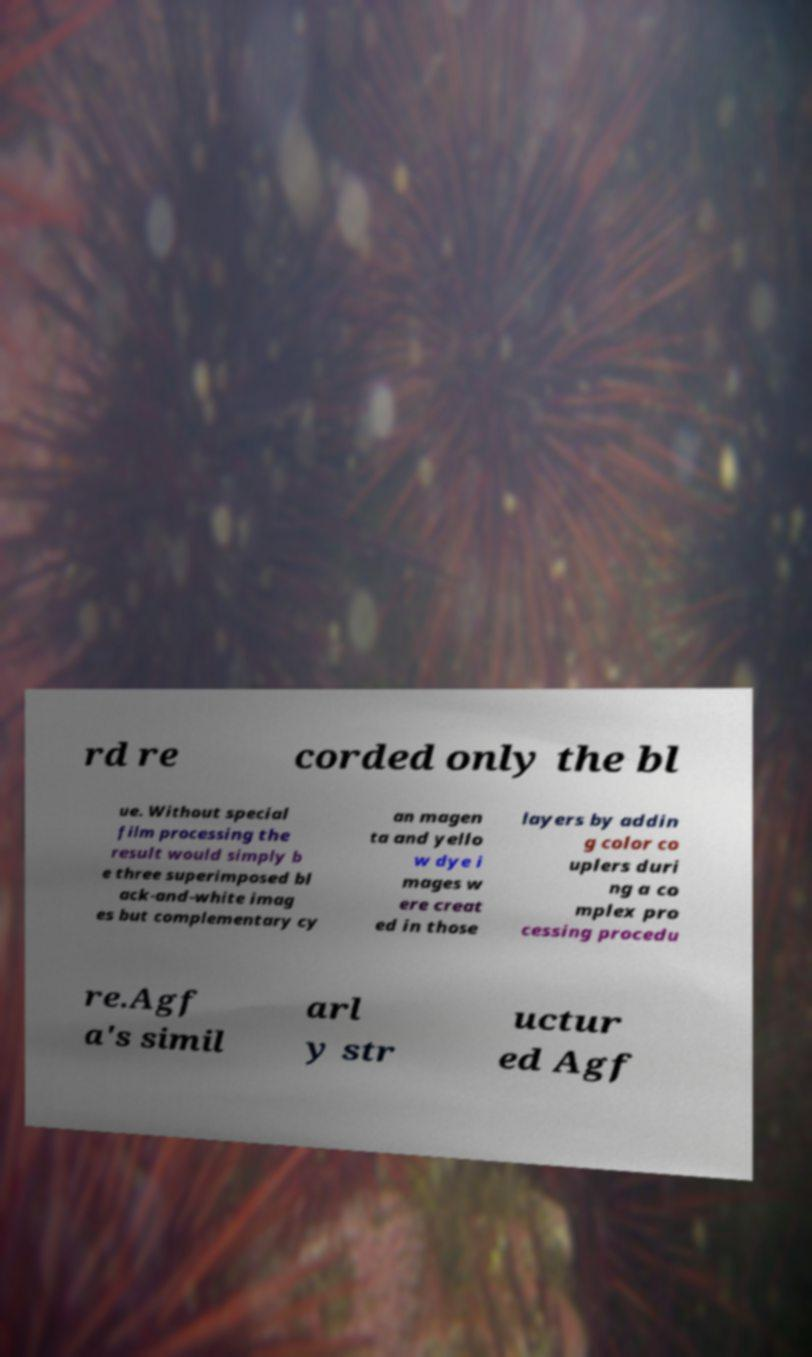What messages or text are displayed in this image? I need them in a readable, typed format. rd re corded only the bl ue. Without special film processing the result would simply b e three superimposed bl ack-and-white imag es but complementary cy an magen ta and yello w dye i mages w ere creat ed in those layers by addin g color co uplers duri ng a co mplex pro cessing procedu re.Agf a's simil arl y str uctur ed Agf 